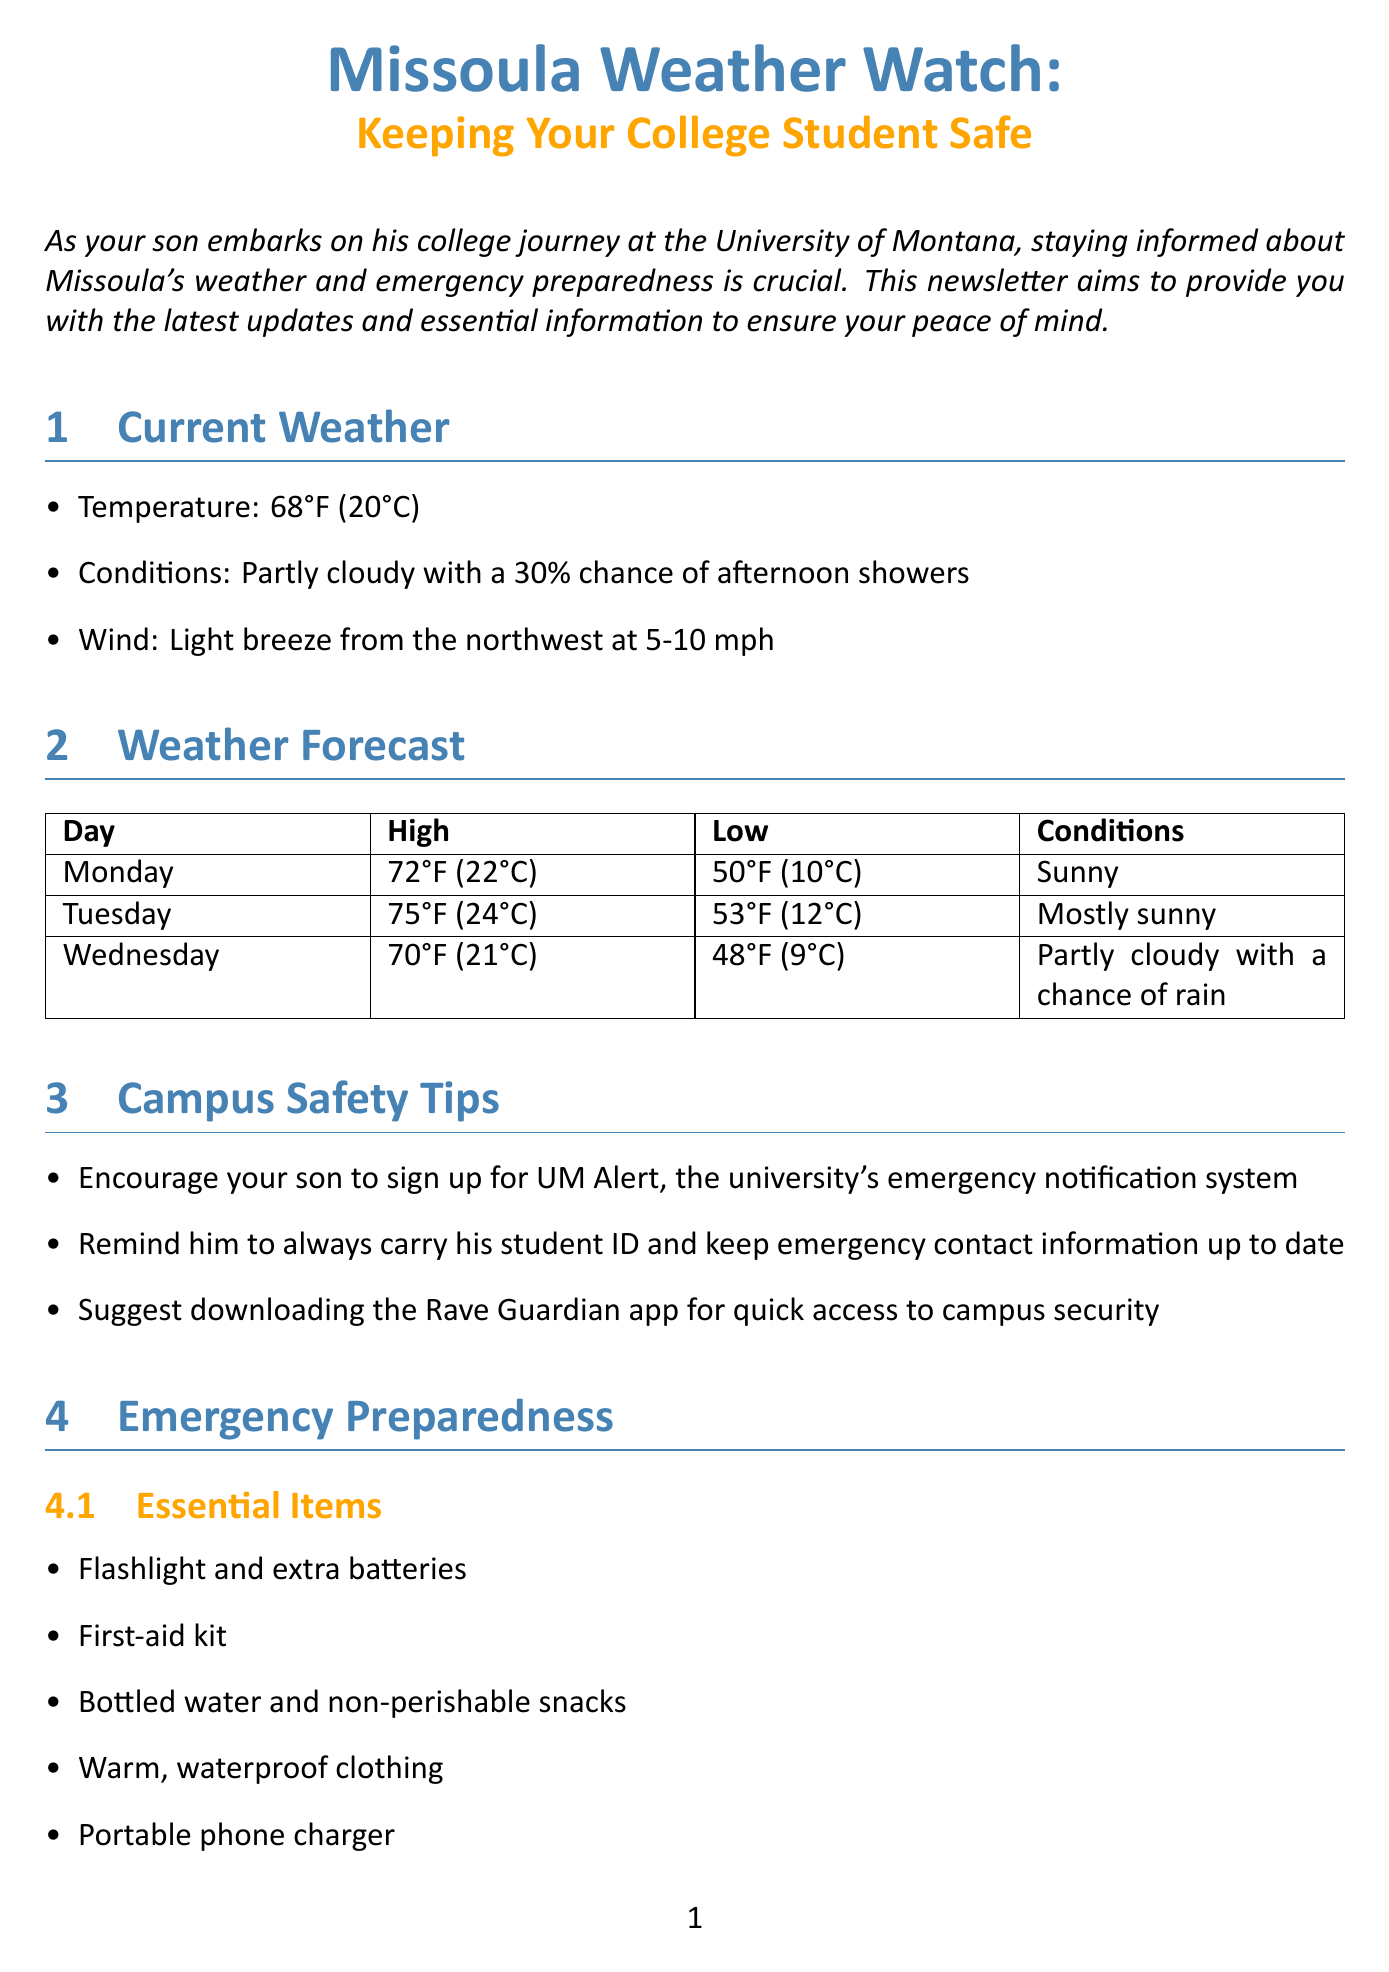What is the current temperature in Missoula? The document states that the current temperature in Missoula is given as 68°F (20°C).
Answer: 68°F (20°C) What should students carry at all times? According to the campus safety tips, students should always carry their student ID.
Answer: Student ID What is the high temperature forecasted for Tuesday? The high temperature for Tuesday is included in the weather forecast section, which shows it as 75°F (24°C).
Answer: 75°F (24°C) Which emergency service's phone number is (406) 243-2122? The document lists important contacts and provides the phone number (406) 243-2122 for Curry Health Center.
Answer: Curry Health Center What essential item is recommended for emergency preparedness that provides light? The essential items section specifies that a flashlight should be included as an essential item for emergency preparedness.
Answer: Flashlight What does the severe weather policy state? The campus-specific information mentions that the University of Montana may cancel classes or close campus in cases of extreme weather.
Answer: Cancel classes or close campus What is the website for the National Weather Service in Missoula? The document lists the website for the National Weather Service in Missoula as https://www.weather.gov/mso/.
Answer: https://www.weather.gov/mso/ What should students have for winter preparedness? The document advises ensuring students have appropriate winter gear, which includes a warm coat.
Answer: Warm coat What is an emergency app suggested for students? The campus safety tips suggest downloading the Rave Guardian app for quick access to campus security.
Answer: Rave Guardian app 